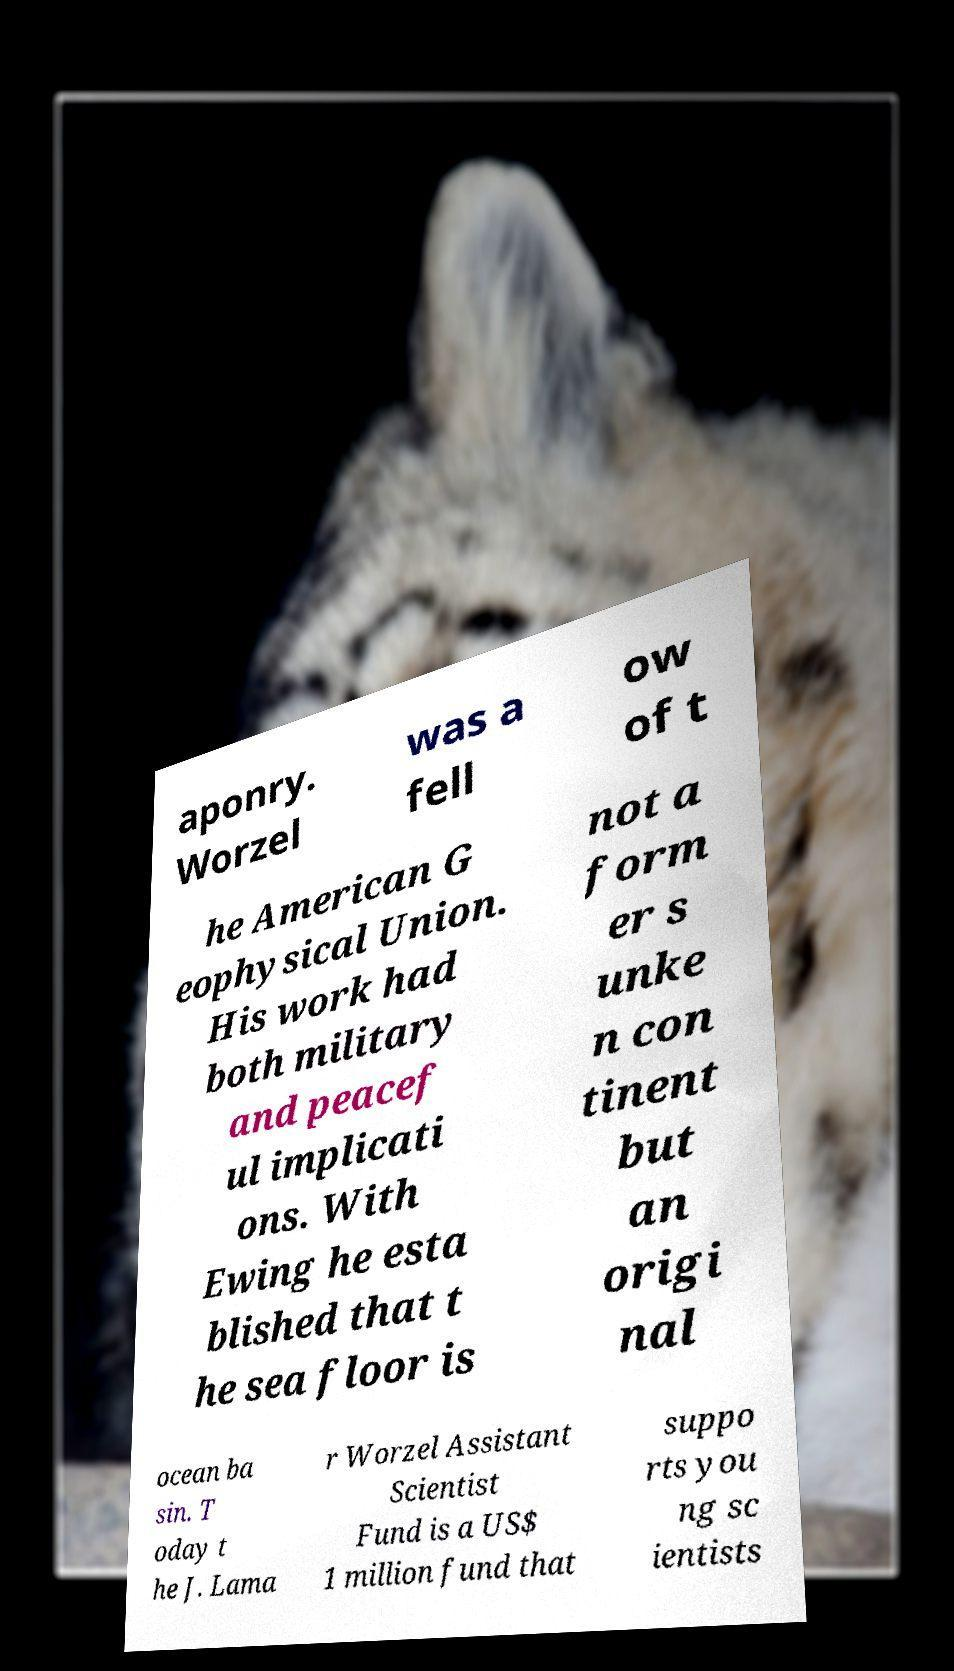Could you assist in decoding the text presented in this image and type it out clearly? aponry. Worzel was a fell ow of t he American G eophysical Union. His work had both military and peacef ul implicati ons. With Ewing he esta blished that t he sea floor is not a form er s unke n con tinent but an origi nal ocean ba sin. T oday t he J. Lama r Worzel Assistant Scientist Fund is a US$ 1 million fund that suppo rts you ng sc ientists 